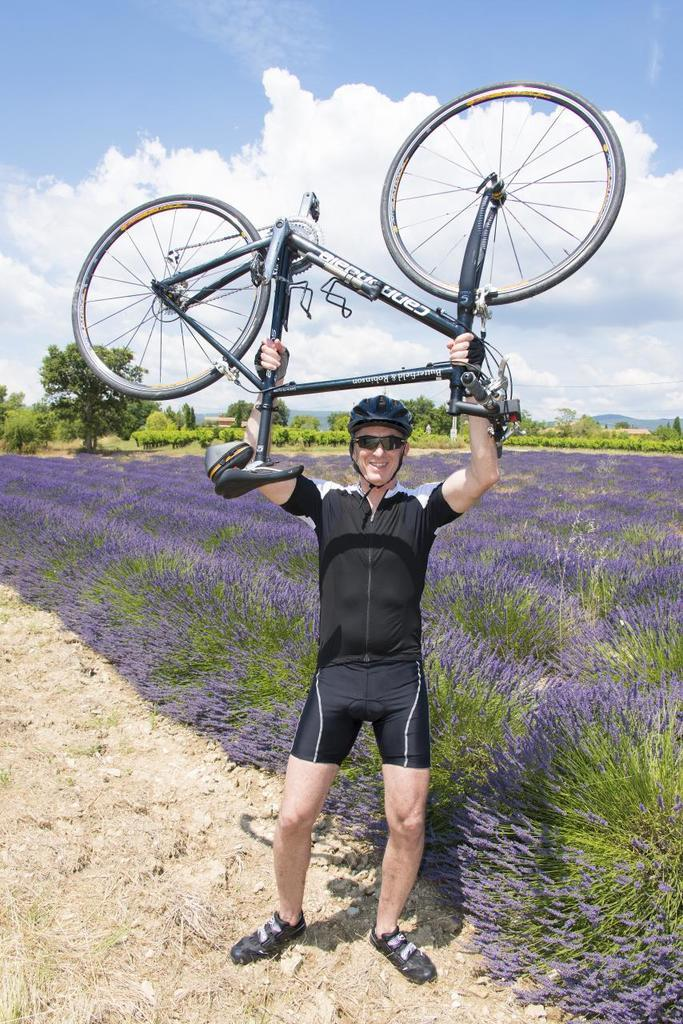What is the main subject of the image? There is a person standing in the middle of the image. What is the person doing in the image? The person is smiling and holding a cycle. What can be seen in the background of the image? There are plants and trees behind the person. What is visible in the sky at the top of the image? There are clouds visible in the sky. What type of hose can be seen in the image? There is no hose present in the image. How does the person's involvement in society affect the image? The image does not provide any information about the person's involvement in society, so it cannot be determined how it affects the image. 